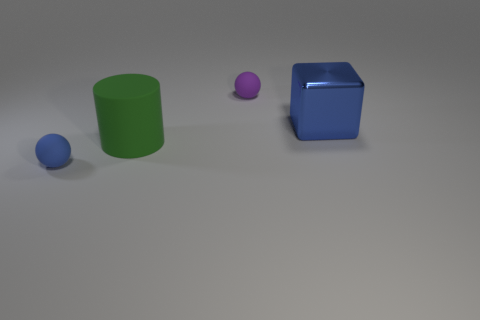Which two objects in the image appear to have the same color? The small ball and the small cube share a similar shade of blue. 